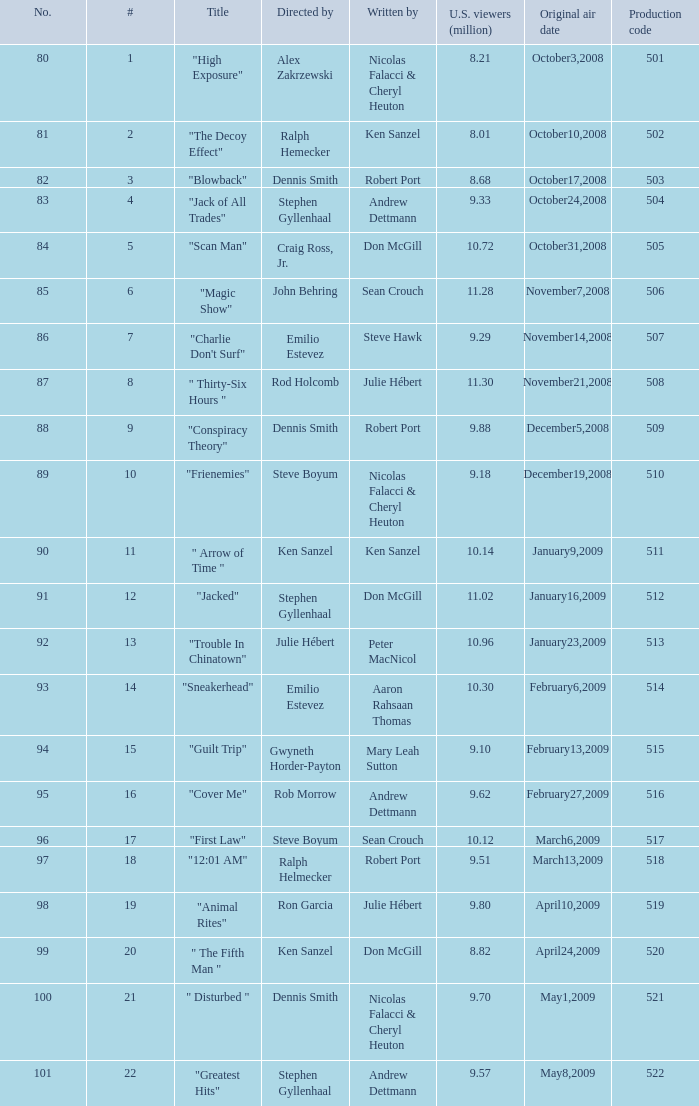Who wrote the episode with the production code 519? Julie Hébert. 